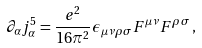<formula> <loc_0><loc_0><loc_500><loc_500>\partial _ { \alpha } j _ { \alpha } ^ { 5 } = \frac { e ^ { 2 } } { 1 6 \pi ^ { 2 } } \epsilon _ { \mu \nu \rho \sigma } F ^ { \mu \nu } F ^ { \rho \sigma } \, ,</formula> 